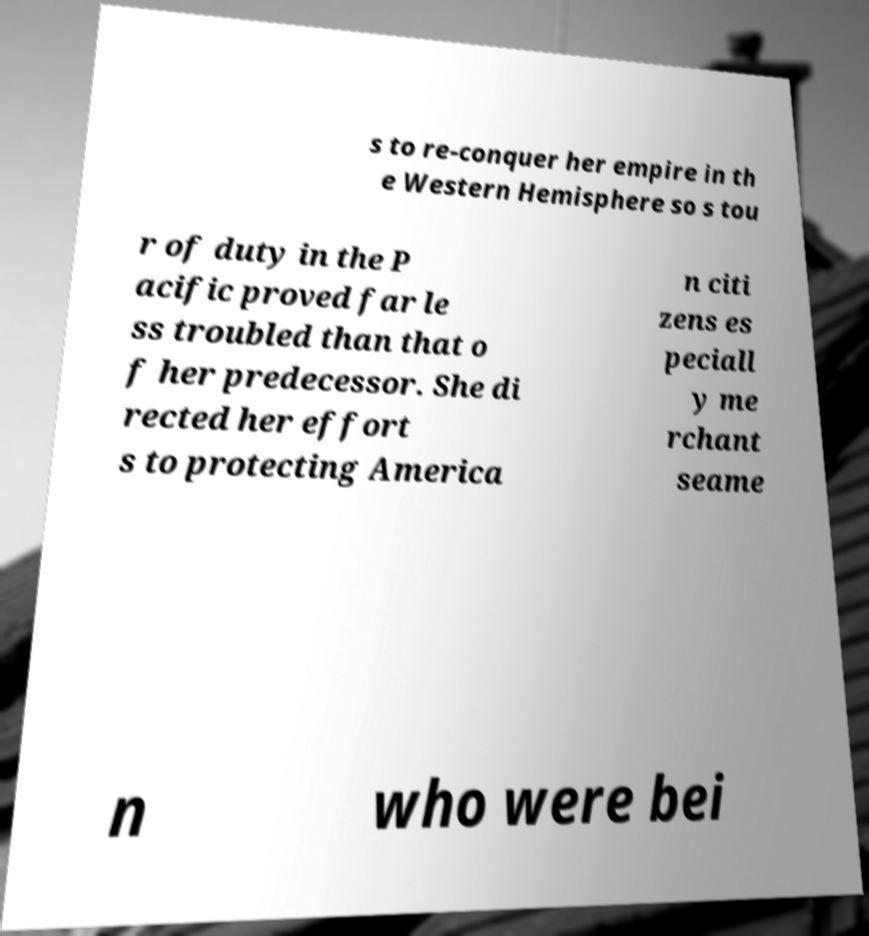Can you accurately transcribe the text from the provided image for me? s to re-conquer her empire in th e Western Hemisphere so s tou r of duty in the P acific proved far le ss troubled than that o f her predecessor. She di rected her effort s to protecting America n citi zens es peciall y me rchant seame n who were bei 